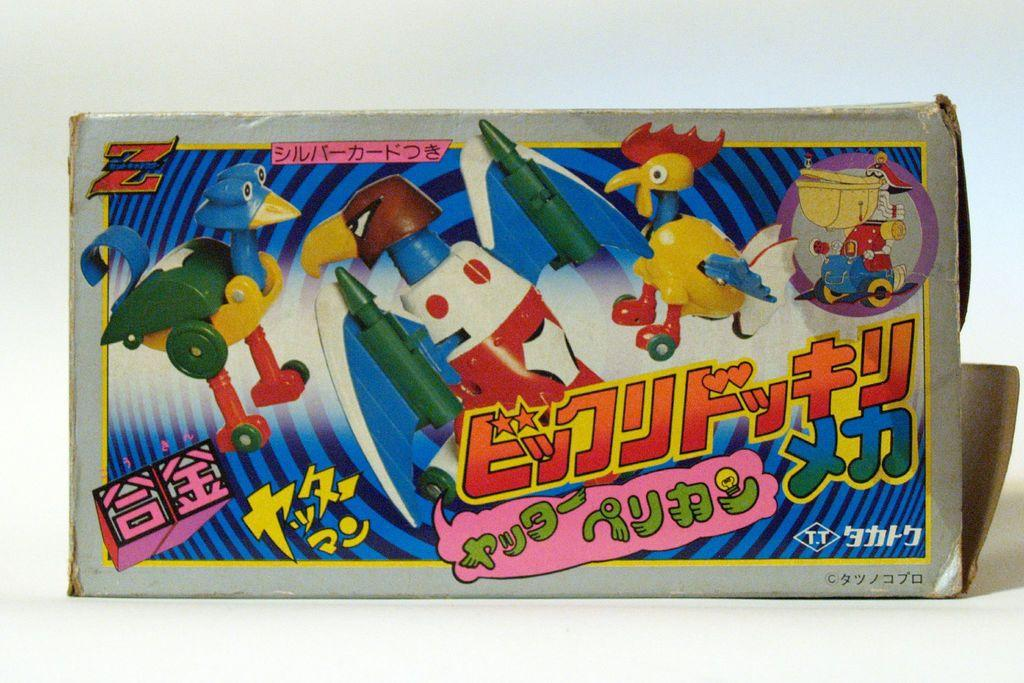What object is present on the white surface in the image? There is a box on the white surface in the image. What is the appearance of the box? The box has a colorful sticker on it. What information is provided on the sticker? The sticker mentions toys and has text on it. What type of hen can be seen participating in the event mentioned on the sticker? There is no hen or event mentioned on the sticker; it only mentions toys and has text on it. 